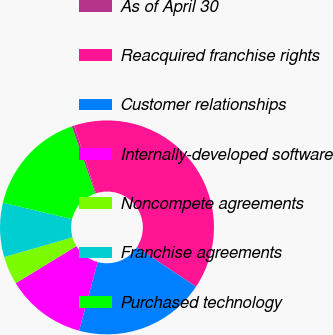Convert chart. <chart><loc_0><loc_0><loc_500><loc_500><pie_chart><fcel>As of April 30<fcel>Reacquired franchise rights<fcel>Customer relationships<fcel>Internally-developed software<fcel>Noncompete agreements<fcel>Franchise agreements<fcel>Purchased technology<nl><fcel>0.38%<fcel>39.31%<fcel>19.85%<fcel>12.06%<fcel>4.27%<fcel>8.17%<fcel>15.95%<nl></chart> 